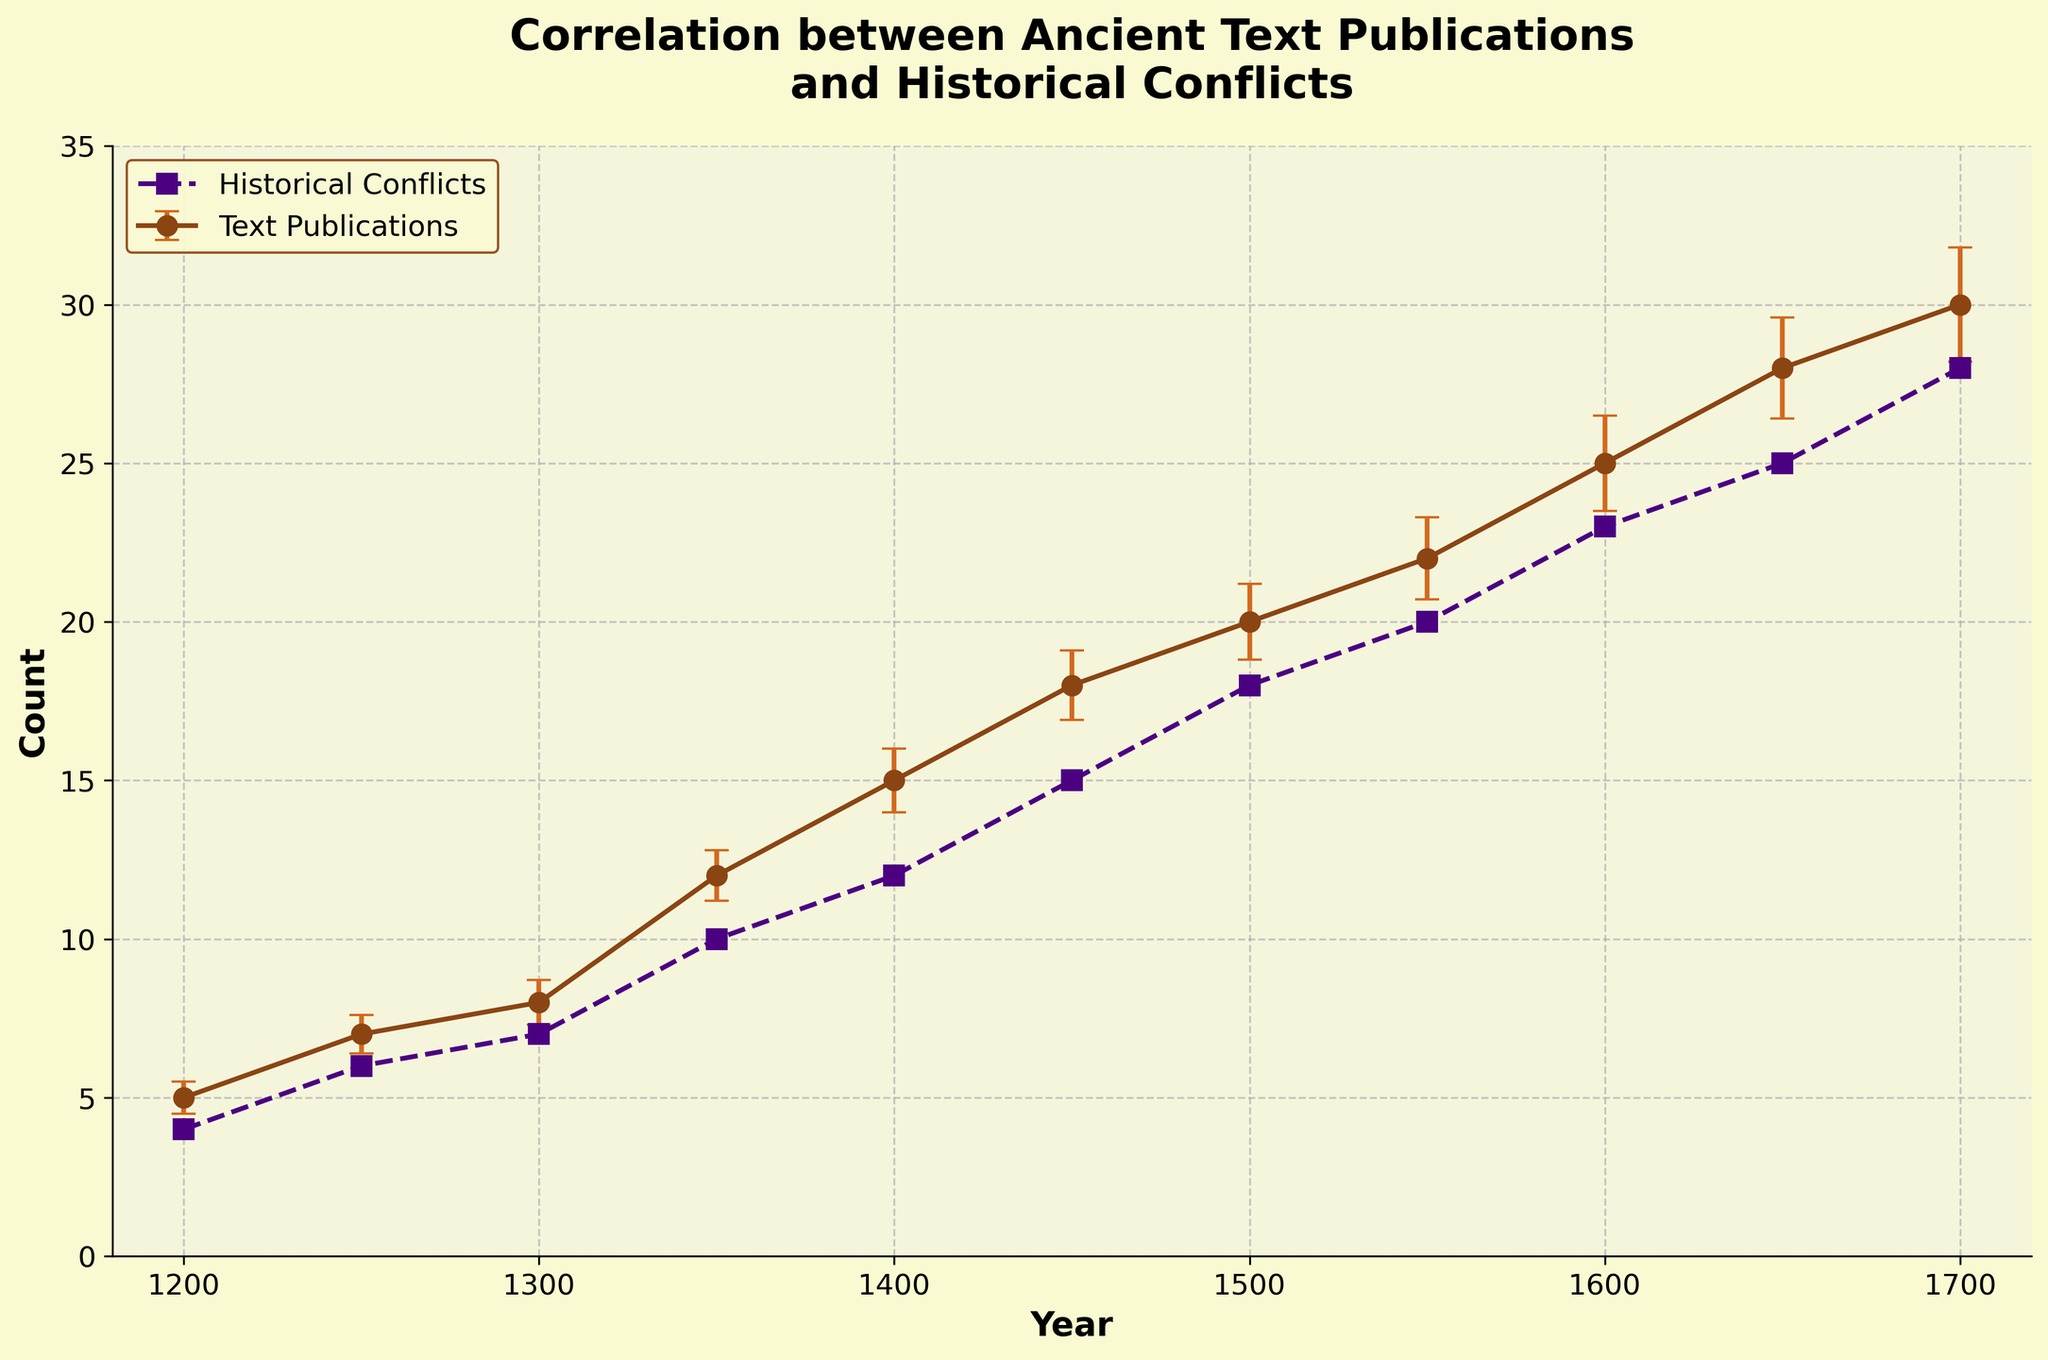What's the title of the figure? The title is displayed above the graph, indicating the main purpose of the figure.
Answer: Correlation between Ancient Text Publications and Historical Conflicts How many data points are there in the figure? By counting the points on the graph for either 'Text Publications' or 'Historical Conflicts', we can determine the number of data points.
Answer: 11 What is the value of the 'Text Publications' count in the year 1500? Locate the year 1500 along the x-axis and find the corresponding y-value for the 'Text Publications' line.
Answer: 20 In which year does the 'Historical Conflicts' count reach 25? Find the y-value of 25 on the 'Historical Conflicts' line and trace it to the corresponding year on the x-axis.
Answer: 1650 How does the number of 'Text Publications' change from 1300 to 1400? Identify the 'Text Publications' count for the years 1300 and 1400 and calculate the difference.
Answer: It increases by 7 What is the difference between 'Text Publications' and 'Historical Conflicts' count in the year 1700? Locate the counts for both 'Text Publications' and 'Historical Conflicts' in the year 1700 and calculate the difference.
Answer: 2 What is the average 'Text Publications' count over the years 1200, 1250, and 1300? Identify the 'Text Publications' counts for 1200, 1250, and 1300, sum them up, and divide by 3.
Answer: (5 + 7 + 8) / 3 = 20 / 3 = 6.67 Which year shows the largest gap between 'Text Publications' and 'Historical Conflicts'? Find the years with the counts for both 'Text Publications' and 'Historical Conflicts' and calculate the differences. The year with the largest difference is the answer.
Answer: 1700 What is the trend of 'Text Publications' counts over time? Observing the 'Text Publications' line over the years, we can summarize the pattern.
Answer: Increasing trend How do 'Text Publications' and 'Historical Conflicts' compare in the year 1600? Locate the counts for both 'Text Publications' and 'Historical Conflicts' in the year 1600 and compare them.
Answer: Text Publications = 25, Historical Conflicts = 23 